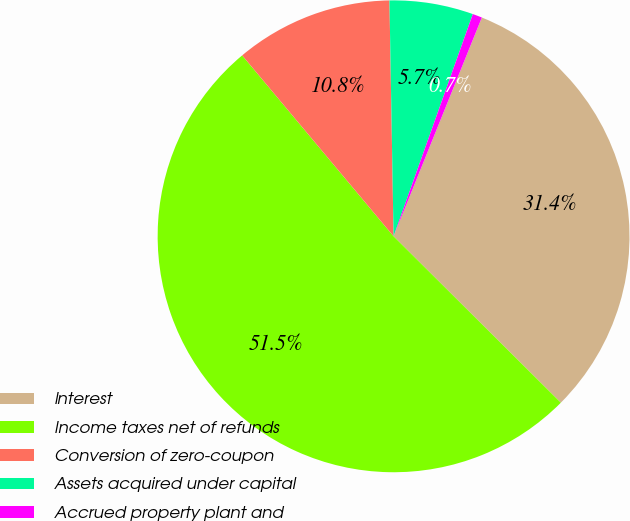Convert chart. <chart><loc_0><loc_0><loc_500><loc_500><pie_chart><fcel>Interest<fcel>Income taxes net of refunds<fcel>Conversion of zero-coupon<fcel>Assets acquired under capital<fcel>Accrued property plant and<nl><fcel>31.35%<fcel>51.44%<fcel>10.81%<fcel>5.73%<fcel>0.65%<nl></chart> 